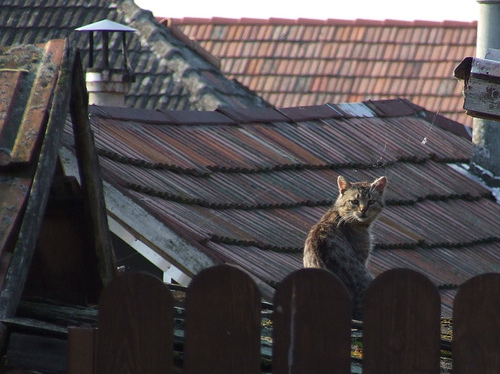<image>
Can you confirm if the cat is on the roof? Yes. Looking at the image, I can see the cat is positioned on top of the roof, with the roof providing support. 